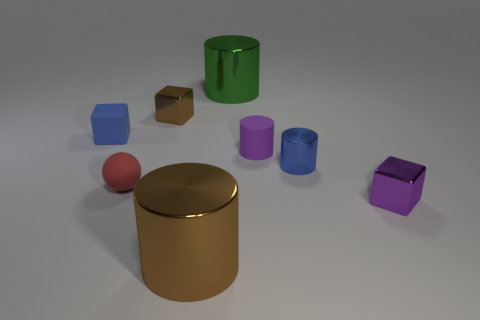There is a shiny cube right of the small blue metal object; does it have the same color as the rubber cylinder?
Your answer should be very brief. Yes. There is a metallic object that is the same color as the matte block; what is its shape?
Your answer should be very brief. Cylinder. Are there any metal blocks of the same color as the small rubber cylinder?
Keep it short and to the point. Yes. Do the small rubber thing right of the brown shiny cylinder and the cube that is on the right side of the green cylinder have the same color?
Keep it short and to the point. Yes. Are the small block in front of the blue matte object and the small purple cylinder made of the same material?
Provide a succinct answer. No. What number of tiny things are both on the right side of the small red matte object and behind the purple metallic object?
Your answer should be compact. 3. There is a tiny shiny block right of the brown object behind the tiny metallic cylinder in front of the tiny purple matte cylinder; what color is it?
Offer a terse response. Purple. What number of other things are there of the same shape as the tiny brown thing?
Make the answer very short. 2. There is a large brown cylinder to the right of the tiny red ball; is there a small brown shiny object that is on the right side of it?
Provide a short and direct response. No. What number of matte things are blue cylinders or big red objects?
Offer a terse response. 0. 